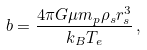<formula> <loc_0><loc_0><loc_500><loc_500>b = \frac { 4 \pi G \mu m _ { p } \rho _ { s } r _ { s } ^ { 3 } } { k _ { B } T _ { e } } \, ,</formula> 